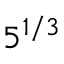<formula> <loc_0><loc_0><loc_500><loc_500>5 ^ { 1 / 3 }</formula> 